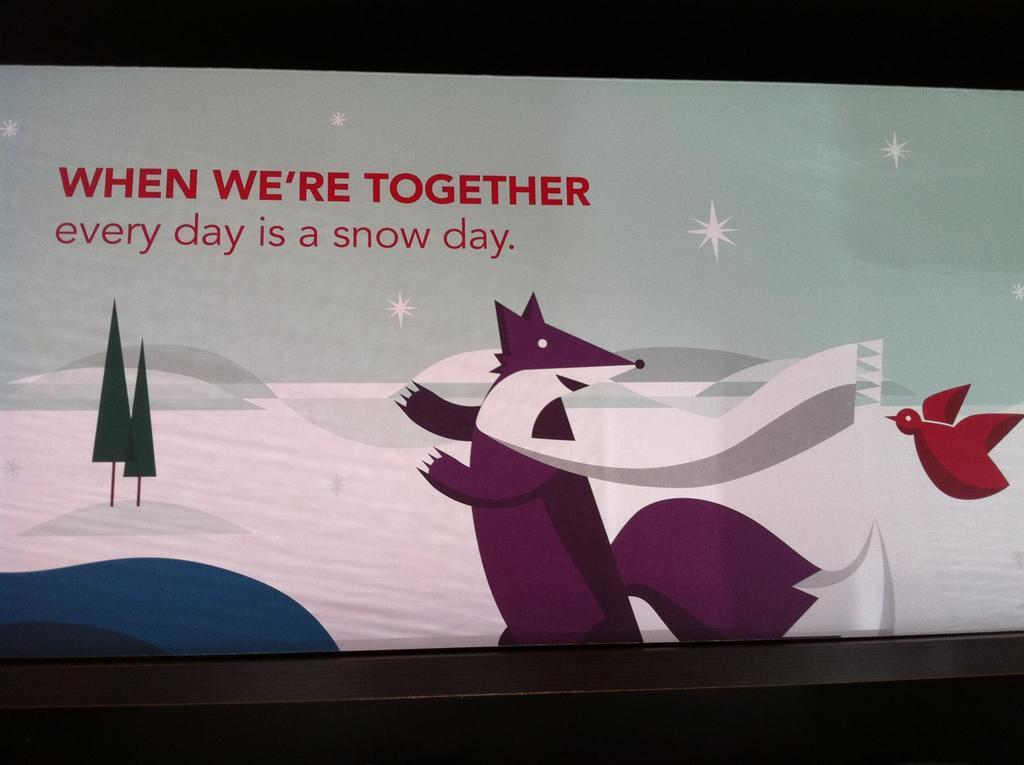What type of image is present in the image? There is a cartoon in the image. What color is the cartoon? The cartoon is in purple color. What animal is present in the image? There is a bird in the image. What color is the bird? The bird is in red color. What type of natural scenery can be seen in the image? There are trees visible in the image. What colors are used for the background of the image? The background of the image is in white and blue color. What type of school can be seen in the image? There is no school present in the image; it features a cartoon with a bird and trees in the background. What type of teeth can be seen in the image? There are no teeth visible in the image, as it features a cartoon with a bird and trees in the background. 